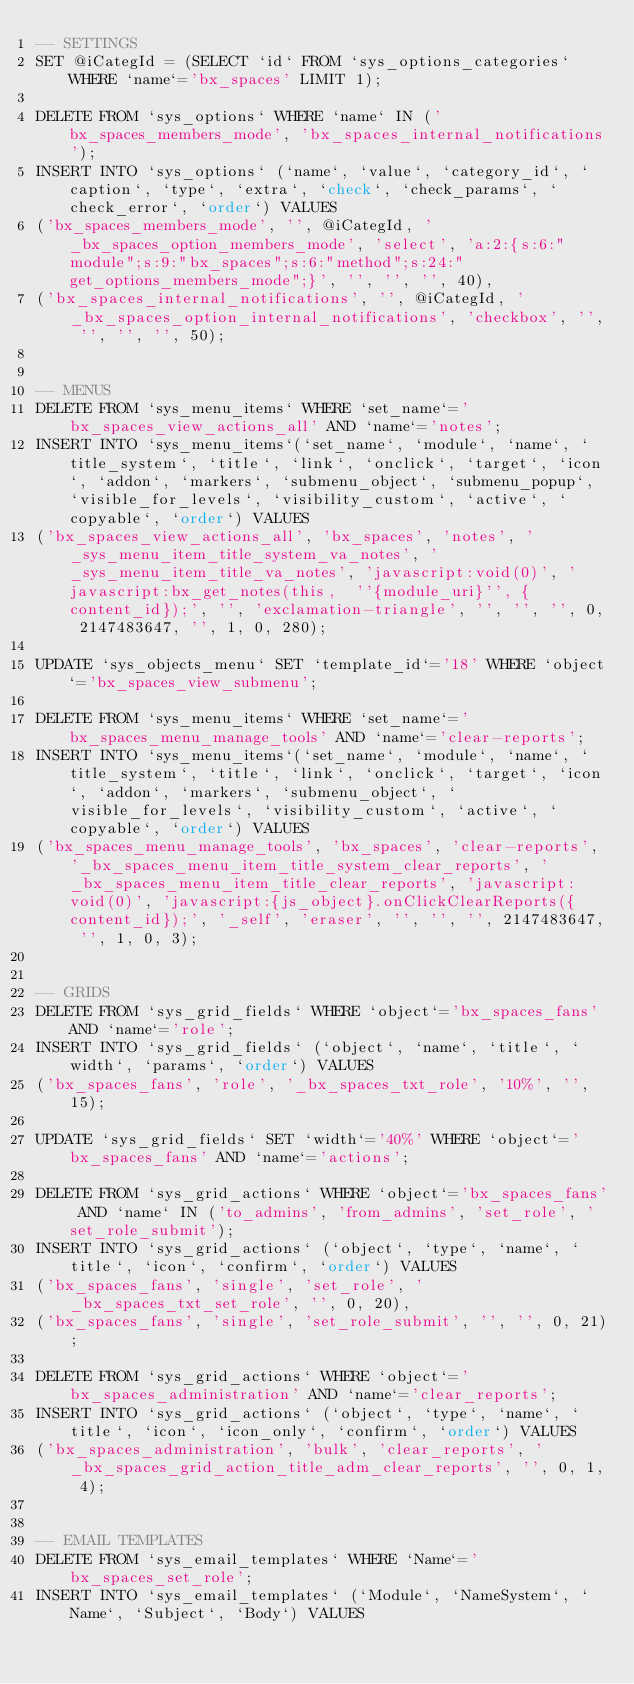Convert code to text. <code><loc_0><loc_0><loc_500><loc_500><_SQL_>-- SETTINGS
SET @iCategId = (SELECT `id` FROM `sys_options_categories` WHERE `name`='bx_spaces' LIMIT 1);

DELETE FROM `sys_options` WHERE `name` IN ('bx_spaces_members_mode', 'bx_spaces_internal_notifications');
INSERT INTO `sys_options` (`name`, `value`, `category_id`, `caption`, `type`, `extra`, `check`, `check_params`, `check_error`, `order`) VALUES
('bx_spaces_members_mode', '', @iCategId, '_bx_spaces_option_members_mode', 'select', 'a:2:{s:6:"module";s:9:"bx_spaces";s:6:"method";s:24:"get_options_members_mode";}', '', '', '', 40),
('bx_spaces_internal_notifications', '', @iCategId, '_bx_spaces_option_internal_notifications', 'checkbox', '', '', '', '', 50);


-- MENUS
DELETE FROM `sys_menu_items` WHERE `set_name`='bx_spaces_view_actions_all' AND `name`='notes';
INSERT INTO `sys_menu_items`(`set_name`, `module`, `name`, `title_system`, `title`, `link`, `onclick`, `target`, `icon`, `addon`, `markers`, `submenu_object`, `submenu_popup`, `visible_for_levels`, `visibility_custom`, `active`, `copyable`, `order`) VALUES 
('bx_spaces_view_actions_all', 'bx_spaces', 'notes', '_sys_menu_item_title_system_va_notes', '_sys_menu_item_title_va_notes', 'javascript:void(0)', 'javascript:bx_get_notes(this,  ''{module_uri}'', {content_id});', '', 'exclamation-triangle', '', '', '', 0, 2147483647, '', 1, 0, 280);

UPDATE `sys_objects_menu` SET `template_id`='18' WHERE `object`='bx_spaces_view_submenu';

DELETE FROM `sys_menu_items` WHERE `set_name`='bx_spaces_menu_manage_tools' AND `name`='clear-reports';
INSERT INTO `sys_menu_items`(`set_name`, `module`, `name`, `title_system`, `title`, `link`, `onclick`, `target`, `icon`, `addon`, `markers`, `submenu_object`, `visible_for_levels`, `visibility_custom`, `active`, `copyable`, `order`) VALUES 
('bx_spaces_menu_manage_tools', 'bx_spaces', 'clear-reports', '_bx_spaces_menu_item_title_system_clear_reports', '_bx_spaces_menu_item_title_clear_reports', 'javascript:void(0)', 'javascript:{js_object}.onClickClearReports({content_id});', '_self', 'eraser', '', '', '', 2147483647, '', 1, 0, 3);


-- GRIDS
DELETE FROM `sys_grid_fields` WHERE `object`='bx_spaces_fans' AND `name`='role';
INSERT INTO `sys_grid_fields` (`object`, `name`, `title`, `width`, `params`, `order`) VALUES
('bx_spaces_fans', 'role', '_bx_spaces_txt_role', '10%', '', 15);

UPDATE `sys_grid_fields` SET `width`='40%' WHERE `object`='bx_spaces_fans' AND `name`='actions';

DELETE FROM `sys_grid_actions` WHERE `object`='bx_spaces_fans' AND `name` IN ('to_admins', 'from_admins', 'set_role', 'set_role_submit');
INSERT INTO `sys_grid_actions` (`object`, `type`, `name`, `title`, `icon`, `confirm`, `order`) VALUES
('bx_spaces_fans', 'single', 'set_role', '_bx_spaces_txt_set_role', '', 0, 20),
('bx_spaces_fans', 'single', 'set_role_submit', '', '', 0, 21);

DELETE FROM `sys_grid_actions` WHERE `object`='bx_spaces_administration' AND `name`='clear_reports';
INSERT INTO `sys_grid_actions` (`object`, `type`, `name`, `title`, `icon`, `icon_only`, `confirm`, `order`) VALUES
('bx_spaces_administration', 'bulk', 'clear_reports', '_bx_spaces_grid_action_title_adm_clear_reports', '', 0, 1, 4);


-- EMAIL TEMPLATES
DELETE FROM `sys_email_templates` WHERE `Name`='bx_spaces_set_role';
INSERT INTO `sys_email_templates` (`Module`, `NameSystem`, `Name`, `Subject`, `Body`) VALUES</code> 